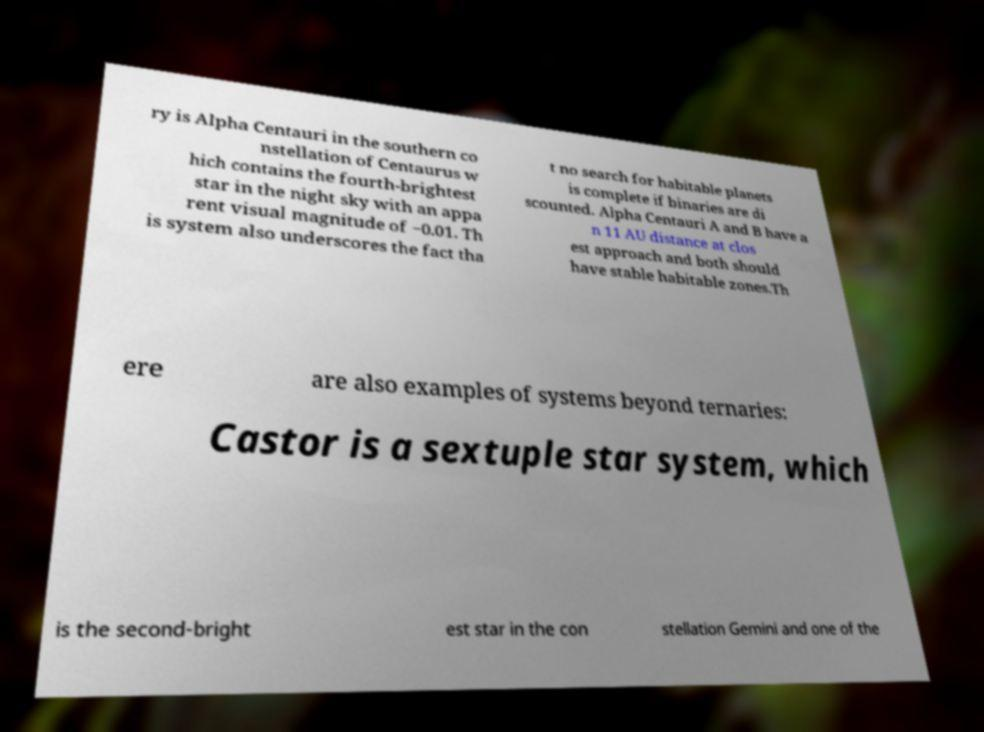For documentation purposes, I need the text within this image transcribed. Could you provide that? ry is Alpha Centauri in the southern co nstellation of Centaurus w hich contains the fourth-brightest star in the night sky with an appa rent visual magnitude of −0.01. Th is system also underscores the fact tha t no search for habitable planets is complete if binaries are di scounted. Alpha Centauri A and B have a n 11 AU distance at clos est approach and both should have stable habitable zones.Th ere are also examples of systems beyond ternaries: Castor is a sextuple star system, which is the second-bright est star in the con stellation Gemini and one of the 